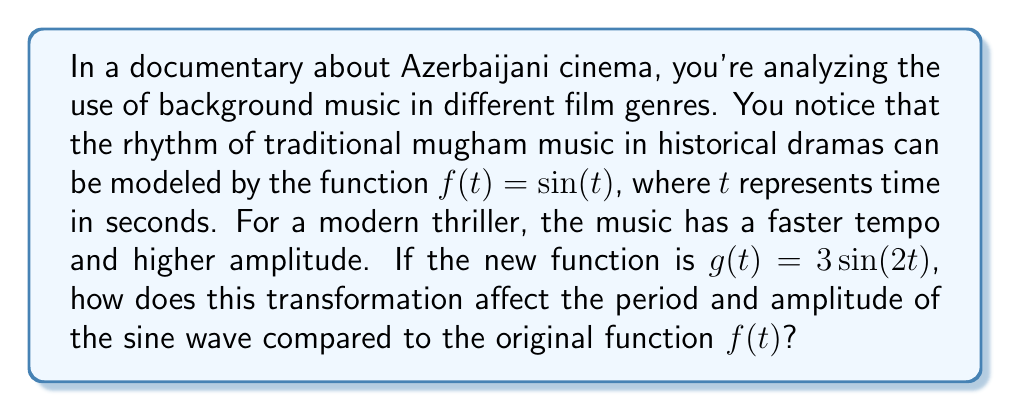Help me with this question. To understand how the transformation affects the sine function, let's analyze the changes step-by-step:

1) Original function: $f(t) = \sin(t)$
   - Period: $2\pi$
   - Amplitude: 1

2) New function: $g(t) = 3\sin(2t)$

3) Analyzing the transformation:
   a) Inside the parentheses: $2t$
      This is a horizontal compression by a factor of 2.
      New period = Original period ÷ 2 = $2\pi \div 2 = \pi$

   b) Outside the parentheses: 3
      This is a vertical stretch by a factor of 3.
      New amplitude = Original amplitude × 3 = 1 × 3 = 3

4) Effects on the graph:
   - The period is halved, meaning the function completes a full cycle in half the time of the original function. This represents the faster tempo of the music in the thriller.
   - The amplitude is tripled, meaning the graph reaches higher peaks and lower troughs. This could represent more dramatic or intense music in the thriller.

5) In the context of film music:
   - Shorter period: Faster rhythm, quicker beats
   - Larger amplitude: More dramatic swells in the music, greater dynamic range

This transformation effectively changes the calm, steady rhythm of traditional mugham music into a more intense, fast-paced soundtrack suitable for a modern thriller.
Answer: The transformation affects the sine wave as follows:
- The period is reduced from $2\pi$ to $\pi$ (halved).
- The amplitude is increased from 1 to 3 (tripled). 